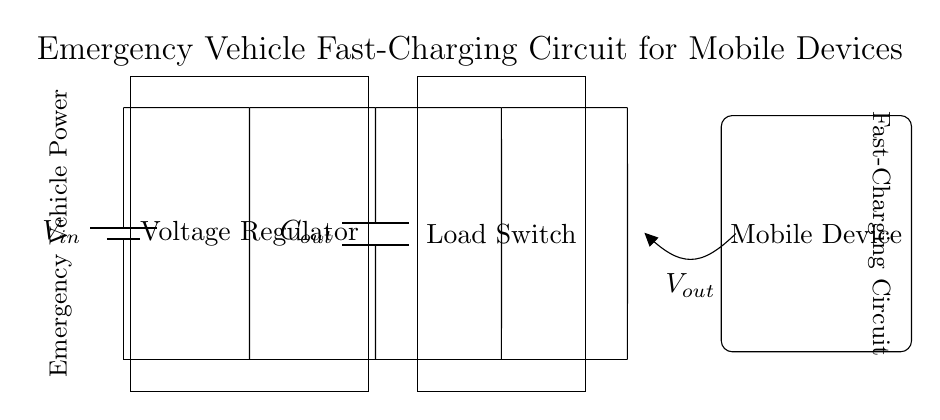What is the input voltage of this circuit? The input voltage is represented by \( V_{in} \) in the circuit, indicating the power source voltage.
Answer: V in What component regulates the output voltage? The voltage regulator regulates the output voltage, ensuring a stable level despite variations in input or load conditions.
Answer: Voltage Regulator What is the purpose of the output capacitor? The output capacitor \( C_{out} \) smoothens out the voltage supply by filtering ripples, ensuring a steady power supply to the load.
Answer: Smooth voltage supply How many main components are in the charging circuit? There are four main components in the circuit: the power source, voltage regulator, load switch, and the output capacitor.
Answer: Four What is the final output of the circuit designated as? The final output is designated as \( V_{out} \), representing the voltage supplied to the connected mobile device.
Answer: V out What role does the load switch play in the circuit? The load switch controls the flow of current to the load (mobile device), allowing it to be turned on or off as needed.
Answer: Control current flow 